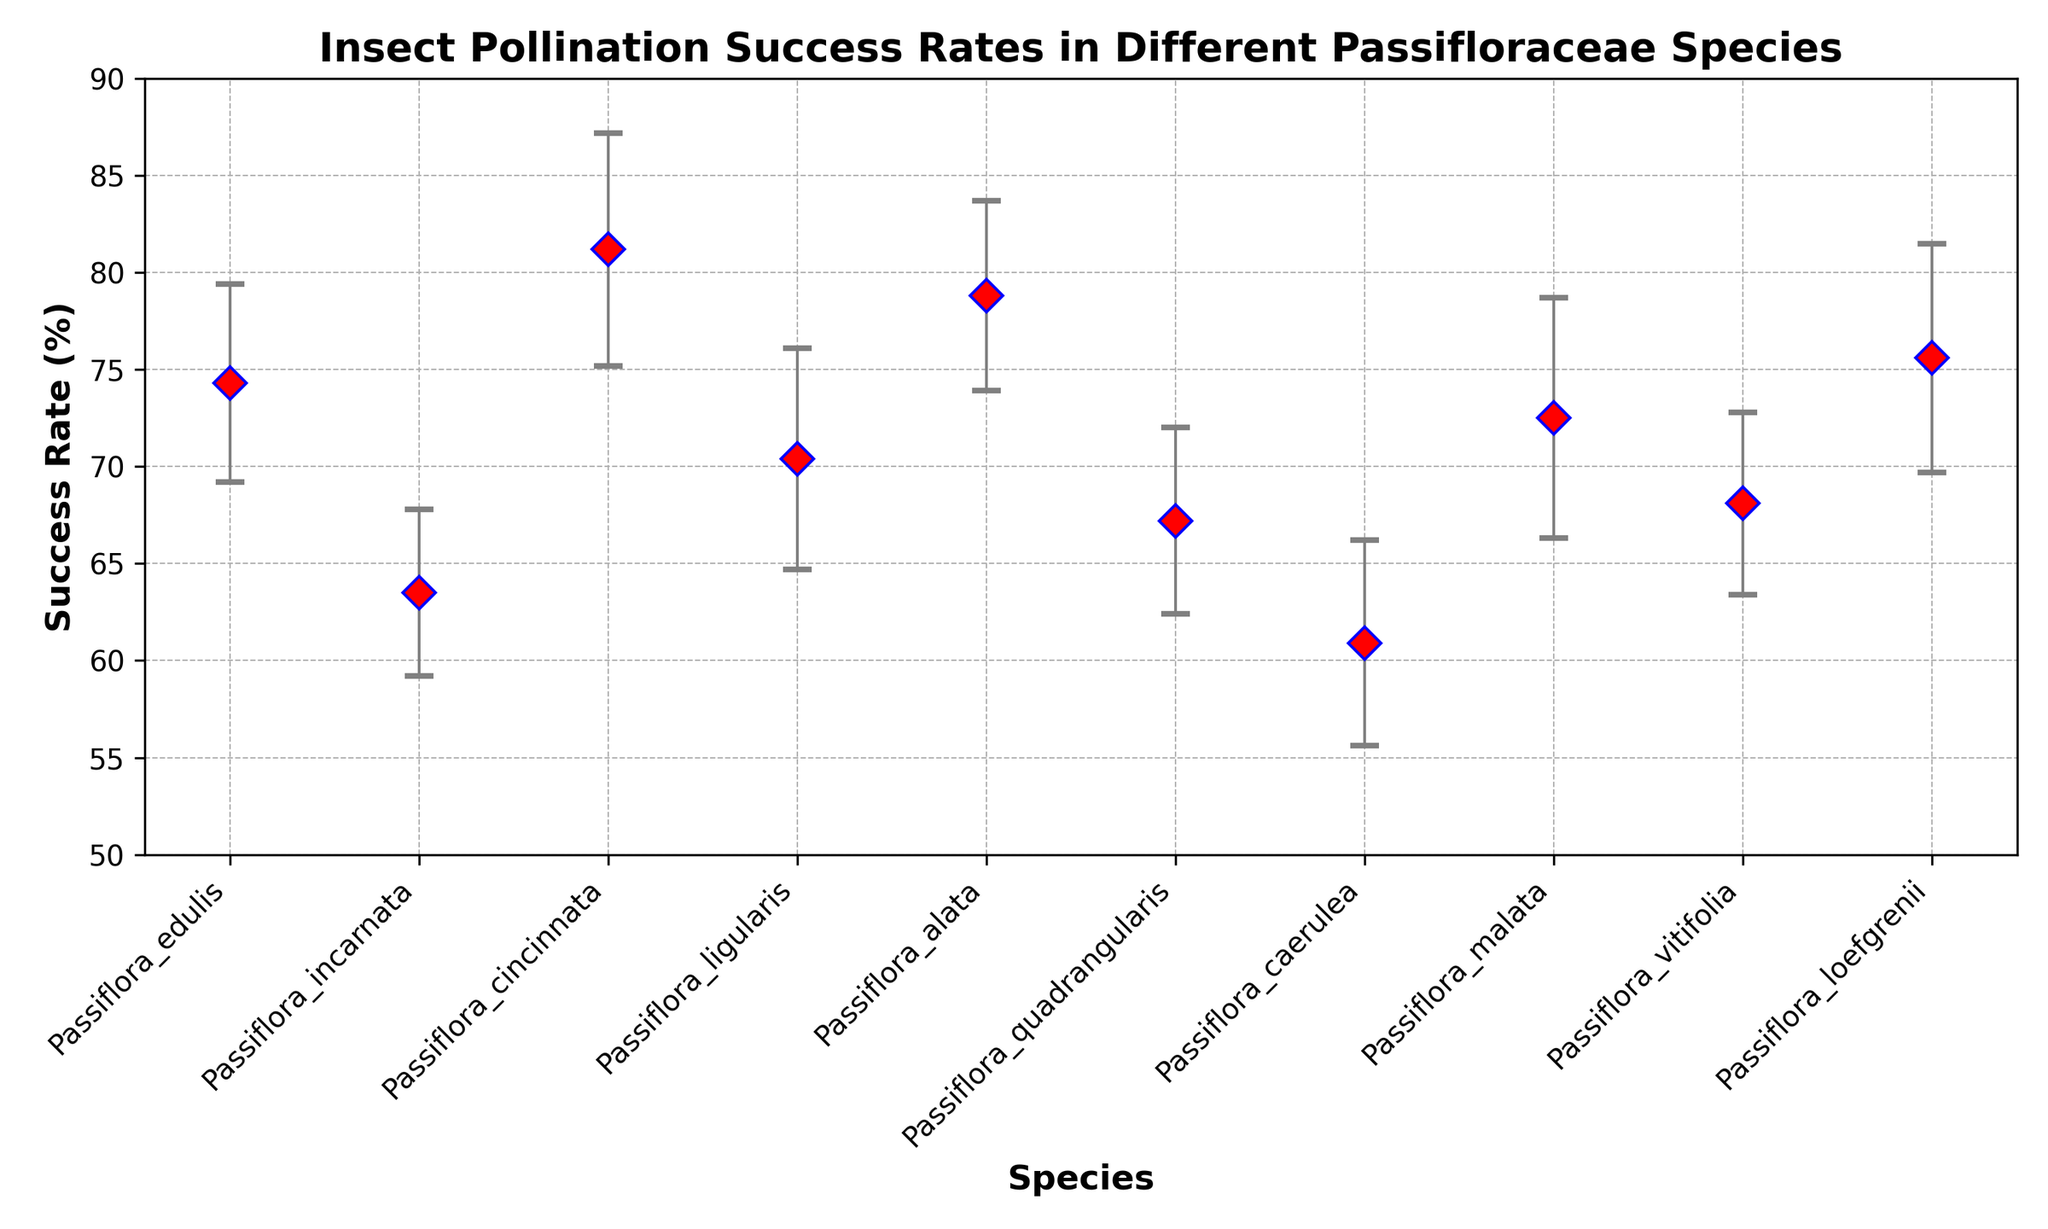Passiflora_cincinnata has the highest insect pollination success rate. What is the rate? By looking at the data points on the plot, we can see that Passiflora_cincinnata shows the highest success rate. The exact value of the success rate can be directly read from the plot.
Answer: 81.2% Which species has the lowest insect pollination success rate? Observing the data points plotted on the figure, Passiflora_caerulea is the species with the lowest success rate.
Answer: Passiflora_caerulea What is the average success rate of Passiflora_edulis, Passiflora_incarnata, and Passiflora_quadrangularis? First, identify the success rates from the plot: Passiflora_edulis (74.3), Passiflora_incarnata (63.5), Passiflora_quadrangularis (67.2). Then, calculate the average: (74.3 + 63.5 + 67.2) / 3 = 205 / 3 = 68.33.
Answer: 68.3% How many species have success rates above 70%? Count the number of data points that are above the 70% mark on the vertical axis.
Answer: 6 What is the difference in success rate between Passiflora_ligularis and Passiflora_vitifolia? Identify the values from the figure: Passiflora_ligularis (70.4) and Passiflora_vitifolia (68.1). Subtract the success rate of Passiflora_vitifolia from that of Passiflora_ligularis: 70.4 - 68.1 = 2.3.
Answer: 2.3% Which species have success rates within one standard error bar of each other? Compare the success rates considering their error bars. Two species have overlapping errors if their success rates plus/minus their respective standard errors intersect or are close.
Answer: Passiflora_vitifolia and Passiflora_quadrangularis How much does the success rate of Passiflora_loefgrenii exceed Passiflora_caerulea? Identify their success rates: Passiflora_loefgrenii (75.6) and Passiflora_caerulea (60.9). Subtract the success rate of Passiflora_caerulea from that of Passiflora_loefgrenii: 75.6 - 60.9 = 14.7.
Answer: 14.7% Which species has the highest standard error, and what is its value? By looking at the error bars, identify the one with the largest error: Passiflora_malata. The exact value can be confirmed from the data.
Answer: 6.2% What is the success rate range covered by the standard error for Passiflora_alata? Identify the success rate and standard error for Passiflora_alata: 78.8 and 4.9, respectively. Calculate the range as 78.8 ± 4.9. This gives 73.9 to 83.7.
Answer: 73.9% to 83.7% Which species have success rates closest to the median success rate across all species? Calculate the median by arranging the success rates in numerical order and finding the middle value (or the average of the two middle values if there is an even number): The median success rate from the data provided is around 71.45. Compare each species' success rate to find the closest ones.
Answer: Passiflora_ligularis and Passiflora_vitifolia 